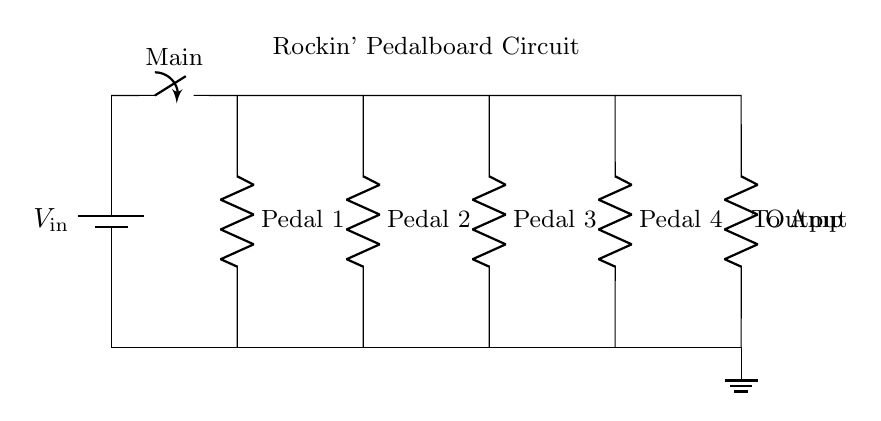What is the function of the main switch? The main switch controls the overall power supply to the circuit, allowing users to turn the entire pedalboard on or off.
Answer: power supply control How many pedals are connected in this circuit? There are four pedals connected in parallel within this circuit, each represented as a resistor in the diagram.
Answer: four What type of circuit is shown? This circuit is a parallel circuit, as it features multiple branches that allow for independent functionality of each pedal while sharing the same voltage input.
Answer: parallel Which component serves as the output? The output component is labeled as 'Output' in the diagram, which likely connects to the guitar amplifier after processing the signal through the pedals.
Answer: Output What does each pedal represent in the circuit? Each pedal in the circuit represents a specific resistance, meaning they are individual effects that modify the guitar signal independently.
Answer: resistance What happens to the voltage supplied to each pedal? In a parallel circuit, the voltage across each pedal remains the same as the input voltage, allowing each one to operate at full power independently.
Answer: same as input voltage What is the total resistance of the circuit? Total resistance in a parallel circuit is calculated using the formula for parallel resistances, but since individual pedal values are not specified, it cannot be determined from the diagram alone.
Answer: cannot be determined 